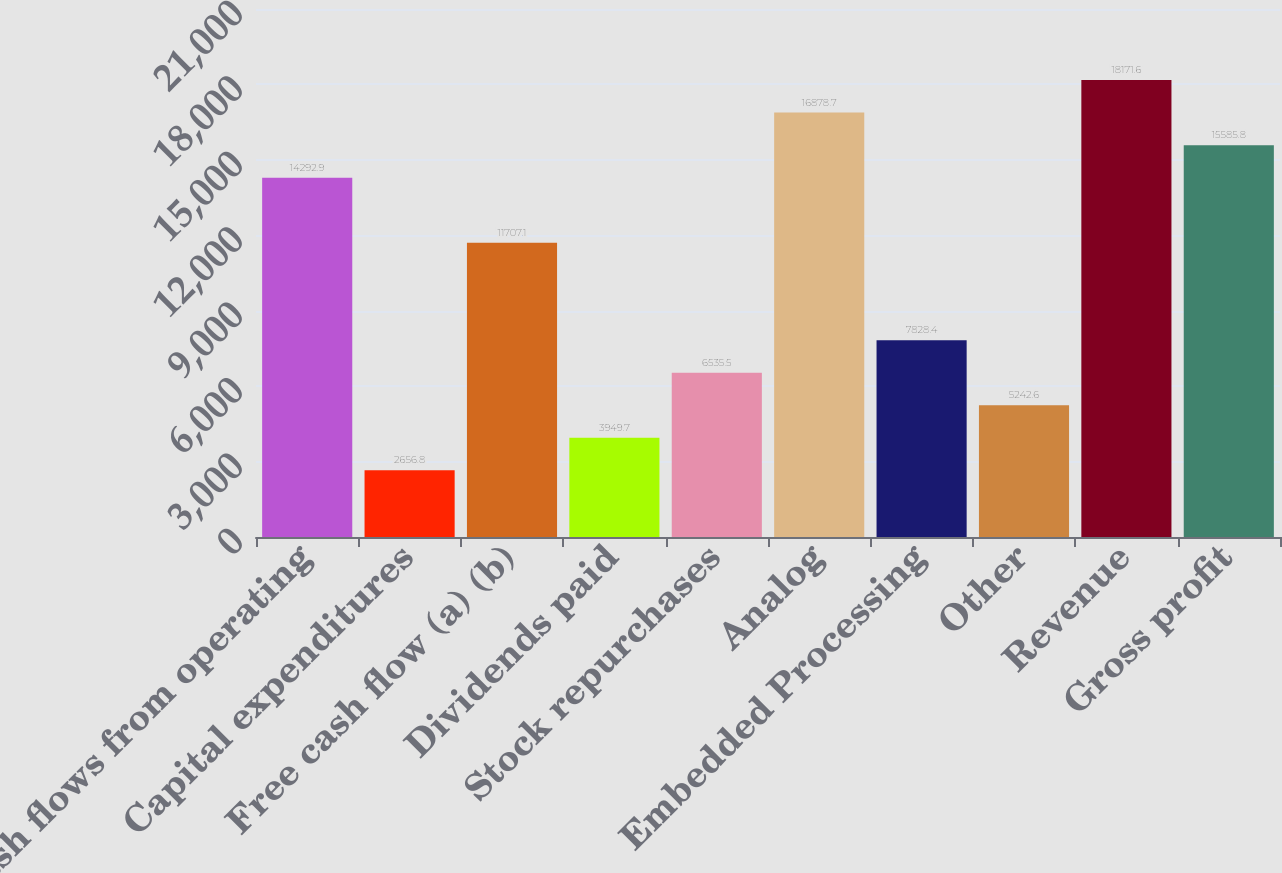Convert chart. <chart><loc_0><loc_0><loc_500><loc_500><bar_chart><fcel>Cash flows from operating<fcel>Capital expenditures<fcel>Free cash flow (a) (b)<fcel>Dividends paid<fcel>Stock repurchases<fcel>Analog<fcel>Embedded Processing<fcel>Other<fcel>Revenue<fcel>Gross profit<nl><fcel>14292.9<fcel>2656.8<fcel>11707.1<fcel>3949.7<fcel>6535.5<fcel>16878.7<fcel>7828.4<fcel>5242.6<fcel>18171.6<fcel>15585.8<nl></chart> 